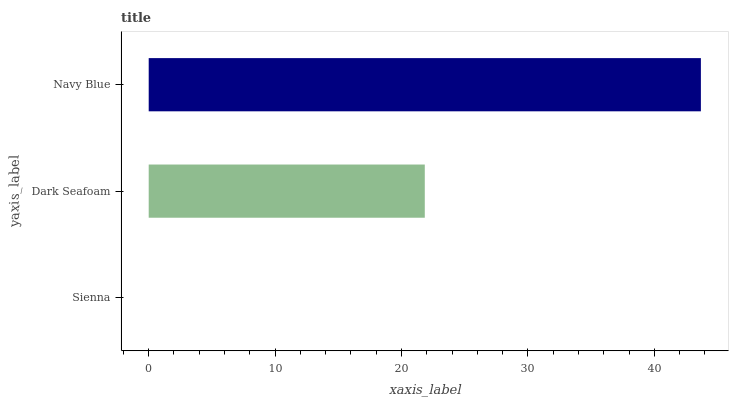Is Sienna the minimum?
Answer yes or no. Yes. Is Navy Blue the maximum?
Answer yes or no. Yes. Is Dark Seafoam the minimum?
Answer yes or no. No. Is Dark Seafoam the maximum?
Answer yes or no. No. Is Dark Seafoam greater than Sienna?
Answer yes or no. Yes. Is Sienna less than Dark Seafoam?
Answer yes or no. Yes. Is Sienna greater than Dark Seafoam?
Answer yes or no. No. Is Dark Seafoam less than Sienna?
Answer yes or no. No. Is Dark Seafoam the high median?
Answer yes or no. Yes. Is Dark Seafoam the low median?
Answer yes or no. Yes. Is Navy Blue the high median?
Answer yes or no. No. Is Sienna the low median?
Answer yes or no. No. 